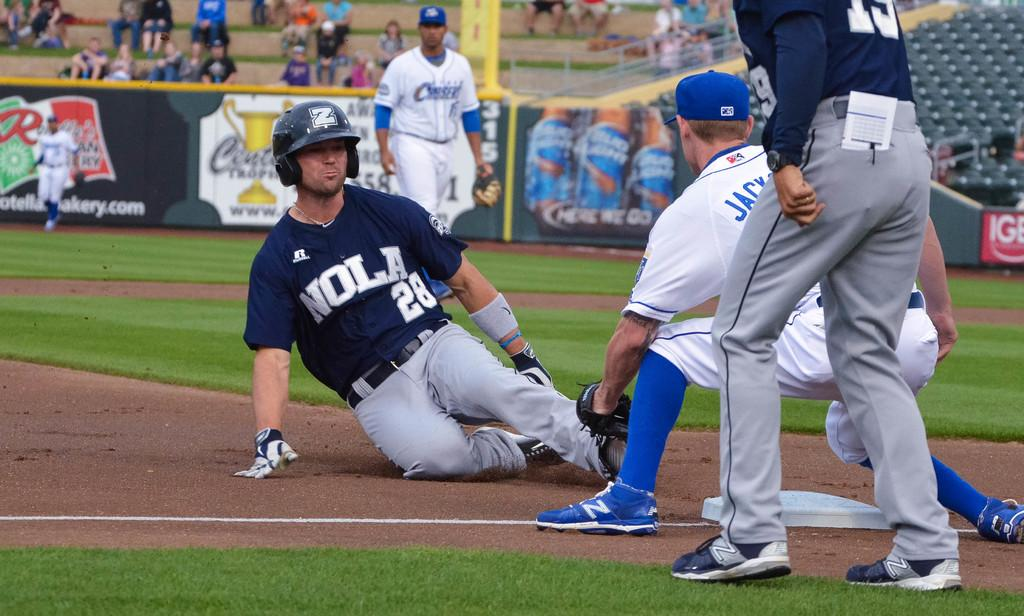<image>
Share a concise interpretation of the image provided. A Nola baseball player is sliding towards the base. 